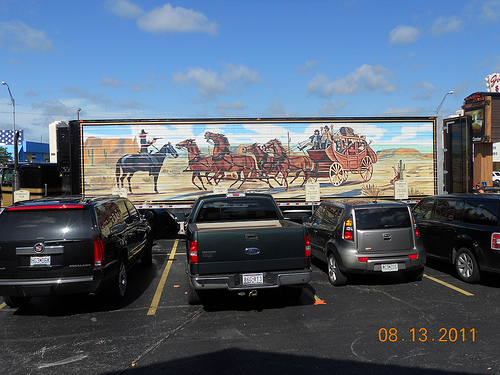<image>
Is there a sky above the road? Yes. The sky is positioned above the road in the vertical space, higher up in the scene. 